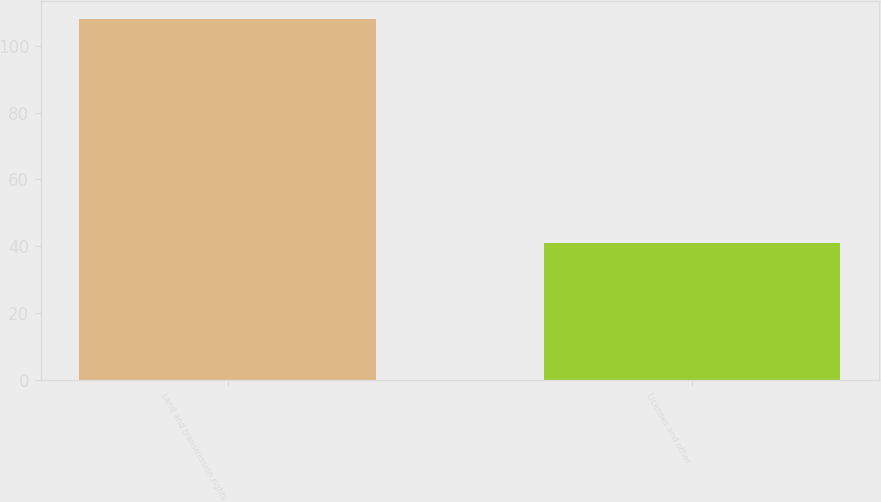Convert chart to OTSL. <chart><loc_0><loc_0><loc_500><loc_500><bar_chart><fcel>Land and transmission rights<fcel>Licenses and other<nl><fcel>108<fcel>41<nl></chart> 